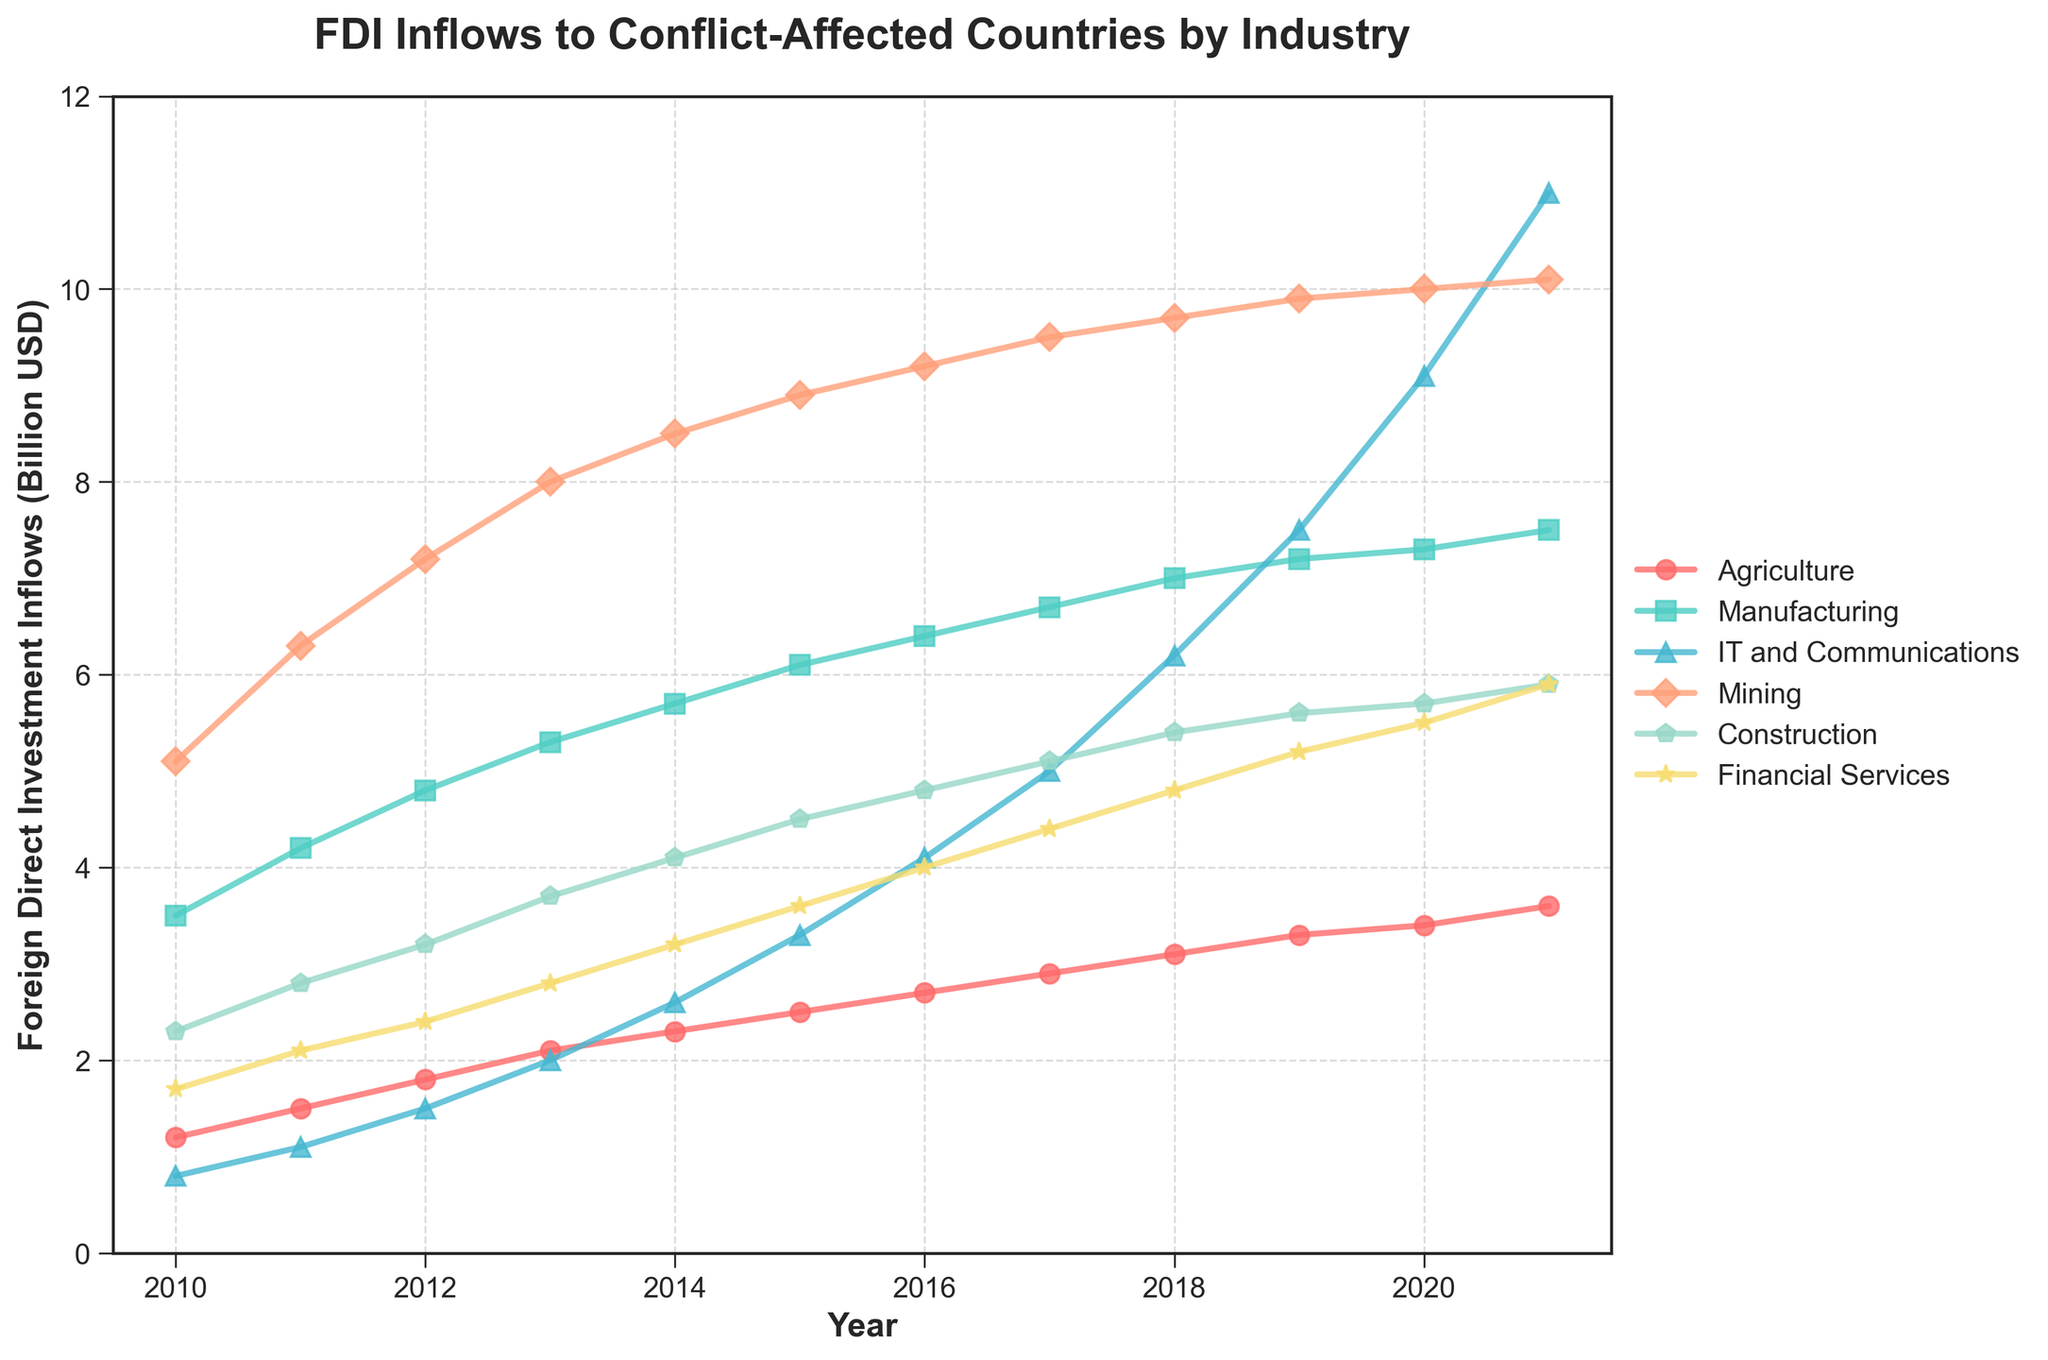What year did IT and Communications surpass Financial Services in FDI inflows? On the chart, IT and Communications surpass Financial Services between 2014 and 2015. Checking the data for these years shows that IT and Communications (3.3) surpasses Financial Services (3.2) in 2015 for the first time.
Answer: 2015 Which industry had the highest increase in FDI inflows from 2010 to 2021? By observing the lines, the IT and Communications industry shows the steepest increase. The FDI for IT and Communications started at 0.8 in 2010 and went up to 11.0 in 2021, an increase of 10.2 billion USD, more than any other industry.
Answer: IT and Communications In 2020, how much higher were the FDI inflows in Manufacturing compared to Agriculture? The FDI inflows for Manufacturing in 2020 were 7.3, and for Agriculture, they were 3.4. The difference is calculated by subtracting the FDI inflows of Agriculture from Manufacturing: 7.3 - 3.4 = 3.9.
Answer: 3.9 billion USD Which industry showed the most consistent growth over the years? By looking at the smoothness and steadiness of the lines, Manufacturing shows the most consistent growth with a steady upward incline without sharp fluctuations.
Answer: Manufacturing What was the total FDI inflows in 2017 across all industries? Add the FDI inflows for all industries in 2017: 2.9 (Agriculture) + 6.7 (Manufacturing) + 5.0 (IT and Communications) + 9.5 (Mining) + 5.1 (Construction) + 4.4 (Financial Services) = 33.6.
Answer: 33.6 billion USD Which two industries were closest to having equal FDI inflows in 2015? Comparing the values in 2015, Construction (4.5) and Financial Services (3.6) are the closest with a difference of 4.5 - 3.6 = 0.9. The next closest industries have larger discrepancies.
Answer: Construction and Financial Services Did any industry experience a decline in FDI inflows over the observed period? Examining all the lines, none of the industries show a decline over the years. All lines indicate growth in FDI inflows from 2010 to 2021.
Answer: No Which industry saw an FDI inflow exactly double another industry in 2021? In 2021, the FDI inflow for IT and Communications was 11.0, which is almost double that of Construction with an FDI inflow of 5.9. The difference isn't perfectly double but it is very close.
Answer: IT and Communications and Construction What's the average FDI inflow for Mining over the 12 years? To calculate the average, add all the values for Mining from 2010 to 2021 and divide by 12: (5.1 + 6.3 + 7.2 + 8.0 + 8.5 + 8.9 + 9.2 + 9.5 + 9.7 + 9.9 + 10.0 + 10.1) / 12 = 8.5083.
Answer: 8.51 billion USD 